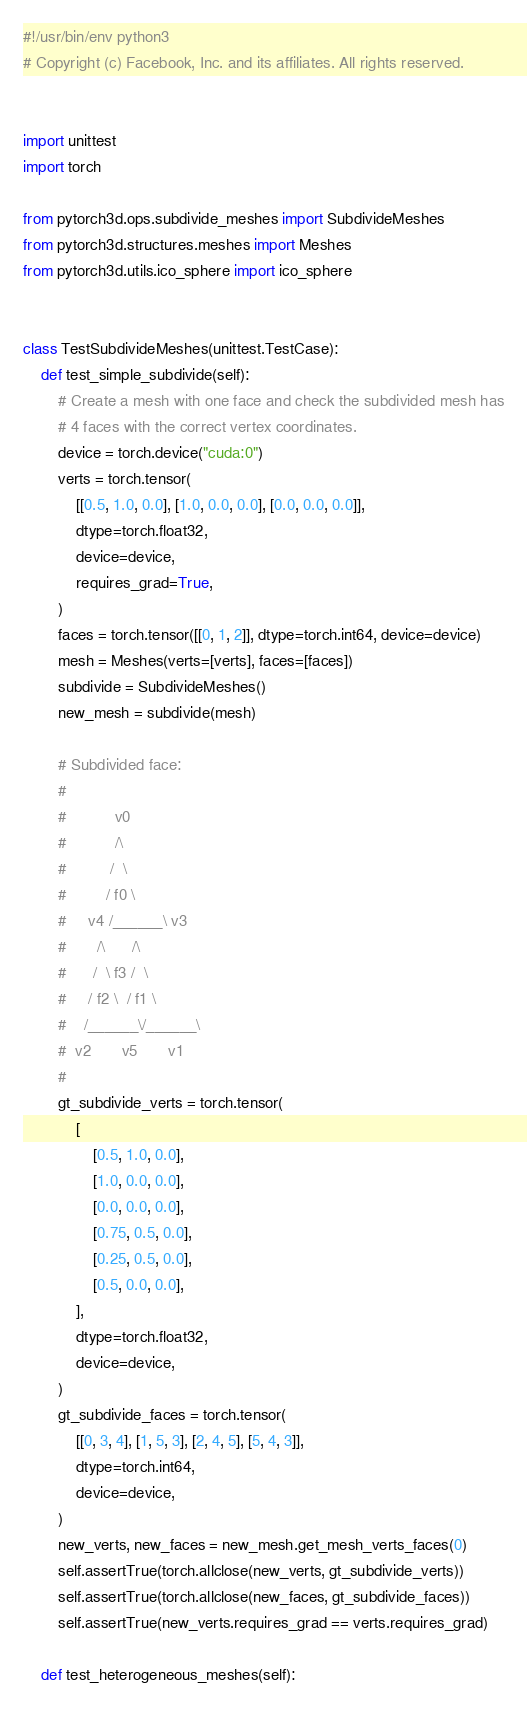<code> <loc_0><loc_0><loc_500><loc_500><_Python_>#!/usr/bin/env python3
# Copyright (c) Facebook, Inc. and its affiliates. All rights reserved.


import unittest
import torch

from pytorch3d.ops.subdivide_meshes import SubdivideMeshes
from pytorch3d.structures.meshes import Meshes
from pytorch3d.utils.ico_sphere import ico_sphere


class TestSubdivideMeshes(unittest.TestCase):
    def test_simple_subdivide(self):
        # Create a mesh with one face and check the subdivided mesh has
        # 4 faces with the correct vertex coordinates.
        device = torch.device("cuda:0")
        verts = torch.tensor(
            [[0.5, 1.0, 0.0], [1.0, 0.0, 0.0], [0.0, 0.0, 0.0]],
            dtype=torch.float32,
            device=device,
            requires_grad=True,
        )
        faces = torch.tensor([[0, 1, 2]], dtype=torch.int64, device=device)
        mesh = Meshes(verts=[verts], faces=[faces])
        subdivide = SubdivideMeshes()
        new_mesh = subdivide(mesh)

        # Subdivided face:
        #
        #           v0
        #           /\
        #          /  \
        #         / f0 \
        #     v4 /______\ v3
        #       /\      /\
        #      /  \ f3 /  \
        #     / f2 \  / f1 \
        #    /______\/______\
        #  v2       v5       v1
        #
        gt_subdivide_verts = torch.tensor(
            [
                [0.5, 1.0, 0.0],
                [1.0, 0.0, 0.0],
                [0.0, 0.0, 0.0],
                [0.75, 0.5, 0.0],
                [0.25, 0.5, 0.0],
                [0.5, 0.0, 0.0],
            ],
            dtype=torch.float32,
            device=device,
        )
        gt_subdivide_faces = torch.tensor(
            [[0, 3, 4], [1, 5, 3], [2, 4, 5], [5, 4, 3]],
            dtype=torch.int64,
            device=device,
        )
        new_verts, new_faces = new_mesh.get_mesh_verts_faces(0)
        self.assertTrue(torch.allclose(new_verts, gt_subdivide_verts))
        self.assertTrue(torch.allclose(new_faces, gt_subdivide_faces))
        self.assertTrue(new_verts.requires_grad == verts.requires_grad)

    def test_heterogeneous_meshes(self):</code> 